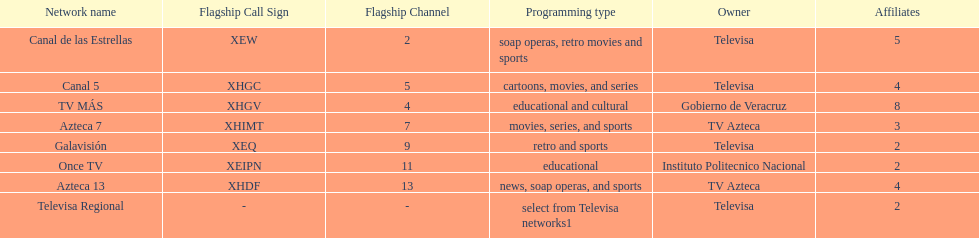What is the number of affiliates of canal de las estrellas. 5. 